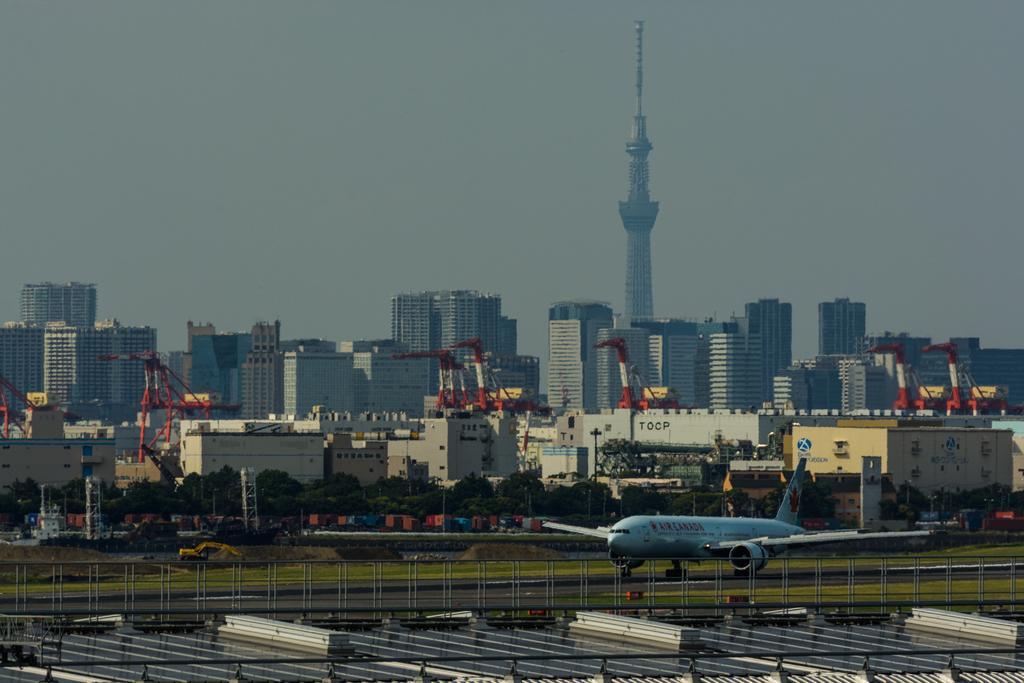Could you give a brief overview of what you see in this image? In the middle there is an aeroplane in white color. There are buildings and trees, at the top it is the sky. 